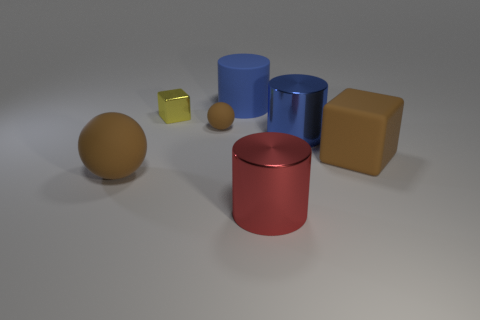Subtract all large blue cylinders. How many cylinders are left? 1 Add 1 cyan cubes. How many objects exist? 8 Subtract all blue cylinders. How many cylinders are left? 1 Subtract all blue cubes. How many blue cylinders are left? 2 Subtract 2 cylinders. How many cylinders are left? 1 Subtract all cubes. How many objects are left? 5 Subtract all small cyan shiny blocks. Subtract all big shiny cylinders. How many objects are left? 5 Add 5 blue shiny cylinders. How many blue shiny cylinders are left? 6 Add 5 brown rubber objects. How many brown rubber objects exist? 8 Subtract 0 cyan blocks. How many objects are left? 7 